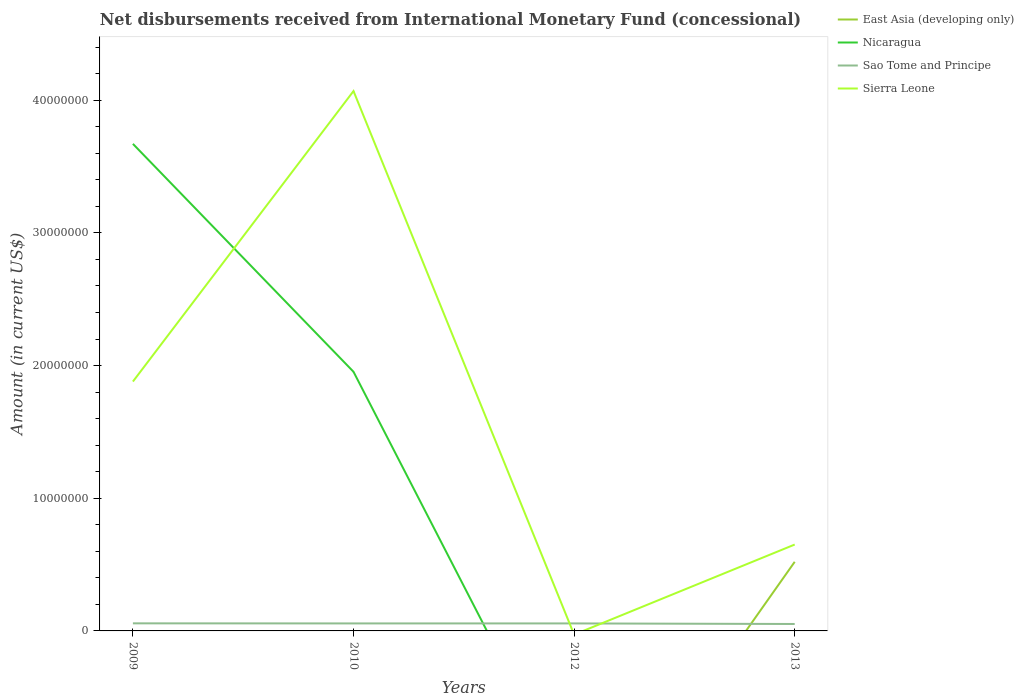Does the line corresponding to Sao Tome and Principe intersect with the line corresponding to Sierra Leone?
Provide a short and direct response. Yes. Across all years, what is the maximum amount of disbursements received from International Monetary Fund in Sao Tome and Principe?
Your answer should be compact. 5.23e+05. What is the total amount of disbursements received from International Monetary Fund in Sierra Leone in the graph?
Provide a short and direct response. 1.23e+07. What is the difference between the highest and the second highest amount of disbursements received from International Monetary Fund in East Asia (developing only)?
Provide a succinct answer. 5.21e+06. Is the amount of disbursements received from International Monetary Fund in Sao Tome and Principe strictly greater than the amount of disbursements received from International Monetary Fund in Sierra Leone over the years?
Provide a succinct answer. No. What is the difference between two consecutive major ticks on the Y-axis?
Offer a very short reply. 1.00e+07. Does the graph contain grids?
Provide a succinct answer. No. How are the legend labels stacked?
Give a very brief answer. Vertical. What is the title of the graph?
Your response must be concise. Net disbursements received from International Monetary Fund (concessional). Does "China" appear as one of the legend labels in the graph?
Provide a succinct answer. No. What is the label or title of the X-axis?
Keep it short and to the point. Years. What is the label or title of the Y-axis?
Keep it short and to the point. Amount (in current US$). What is the Amount (in current US$) of East Asia (developing only) in 2009?
Offer a very short reply. 0. What is the Amount (in current US$) in Nicaragua in 2009?
Keep it short and to the point. 3.67e+07. What is the Amount (in current US$) of Sao Tome and Principe in 2009?
Keep it short and to the point. 5.71e+05. What is the Amount (in current US$) of Sierra Leone in 2009?
Your response must be concise. 1.88e+07. What is the Amount (in current US$) of East Asia (developing only) in 2010?
Make the answer very short. 0. What is the Amount (in current US$) in Nicaragua in 2010?
Offer a terse response. 1.95e+07. What is the Amount (in current US$) of Sao Tome and Principe in 2010?
Your response must be concise. 5.65e+05. What is the Amount (in current US$) of Sierra Leone in 2010?
Make the answer very short. 4.07e+07. What is the Amount (in current US$) in East Asia (developing only) in 2012?
Your answer should be very brief. 0. What is the Amount (in current US$) of Nicaragua in 2012?
Keep it short and to the point. 0. What is the Amount (in current US$) in Sao Tome and Principe in 2012?
Provide a succinct answer. 5.65e+05. What is the Amount (in current US$) of East Asia (developing only) in 2013?
Keep it short and to the point. 5.21e+06. What is the Amount (in current US$) of Nicaragua in 2013?
Ensure brevity in your answer.  0. What is the Amount (in current US$) of Sao Tome and Principe in 2013?
Make the answer very short. 5.23e+05. What is the Amount (in current US$) of Sierra Leone in 2013?
Give a very brief answer. 6.51e+06. Across all years, what is the maximum Amount (in current US$) in East Asia (developing only)?
Give a very brief answer. 5.21e+06. Across all years, what is the maximum Amount (in current US$) of Nicaragua?
Ensure brevity in your answer.  3.67e+07. Across all years, what is the maximum Amount (in current US$) in Sao Tome and Principe?
Keep it short and to the point. 5.71e+05. Across all years, what is the maximum Amount (in current US$) in Sierra Leone?
Offer a very short reply. 4.07e+07. Across all years, what is the minimum Amount (in current US$) of East Asia (developing only)?
Give a very brief answer. 0. Across all years, what is the minimum Amount (in current US$) of Sao Tome and Principe?
Provide a short and direct response. 5.23e+05. Across all years, what is the minimum Amount (in current US$) of Sierra Leone?
Provide a short and direct response. 0. What is the total Amount (in current US$) in East Asia (developing only) in the graph?
Your response must be concise. 5.21e+06. What is the total Amount (in current US$) of Nicaragua in the graph?
Offer a very short reply. 5.62e+07. What is the total Amount (in current US$) in Sao Tome and Principe in the graph?
Provide a succinct answer. 2.22e+06. What is the total Amount (in current US$) in Sierra Leone in the graph?
Give a very brief answer. 6.60e+07. What is the difference between the Amount (in current US$) in Nicaragua in 2009 and that in 2010?
Give a very brief answer. 1.72e+07. What is the difference between the Amount (in current US$) in Sao Tome and Principe in 2009 and that in 2010?
Your answer should be compact. 6000. What is the difference between the Amount (in current US$) in Sierra Leone in 2009 and that in 2010?
Give a very brief answer. -2.19e+07. What is the difference between the Amount (in current US$) of Sao Tome and Principe in 2009 and that in 2012?
Offer a terse response. 6000. What is the difference between the Amount (in current US$) of Sao Tome and Principe in 2009 and that in 2013?
Your response must be concise. 4.80e+04. What is the difference between the Amount (in current US$) in Sierra Leone in 2009 and that in 2013?
Your response must be concise. 1.23e+07. What is the difference between the Amount (in current US$) of Sao Tome and Principe in 2010 and that in 2013?
Your response must be concise. 4.20e+04. What is the difference between the Amount (in current US$) in Sierra Leone in 2010 and that in 2013?
Offer a terse response. 3.42e+07. What is the difference between the Amount (in current US$) of Sao Tome and Principe in 2012 and that in 2013?
Your answer should be very brief. 4.20e+04. What is the difference between the Amount (in current US$) in Nicaragua in 2009 and the Amount (in current US$) in Sao Tome and Principe in 2010?
Provide a short and direct response. 3.61e+07. What is the difference between the Amount (in current US$) in Nicaragua in 2009 and the Amount (in current US$) in Sierra Leone in 2010?
Provide a succinct answer. -3.98e+06. What is the difference between the Amount (in current US$) of Sao Tome and Principe in 2009 and the Amount (in current US$) of Sierra Leone in 2010?
Provide a succinct answer. -4.01e+07. What is the difference between the Amount (in current US$) of Nicaragua in 2009 and the Amount (in current US$) of Sao Tome and Principe in 2012?
Offer a very short reply. 3.61e+07. What is the difference between the Amount (in current US$) of Nicaragua in 2009 and the Amount (in current US$) of Sao Tome and Principe in 2013?
Ensure brevity in your answer.  3.62e+07. What is the difference between the Amount (in current US$) in Nicaragua in 2009 and the Amount (in current US$) in Sierra Leone in 2013?
Your response must be concise. 3.02e+07. What is the difference between the Amount (in current US$) in Sao Tome and Principe in 2009 and the Amount (in current US$) in Sierra Leone in 2013?
Offer a terse response. -5.94e+06. What is the difference between the Amount (in current US$) of Nicaragua in 2010 and the Amount (in current US$) of Sao Tome and Principe in 2012?
Make the answer very short. 1.90e+07. What is the difference between the Amount (in current US$) of Nicaragua in 2010 and the Amount (in current US$) of Sao Tome and Principe in 2013?
Give a very brief answer. 1.90e+07. What is the difference between the Amount (in current US$) in Nicaragua in 2010 and the Amount (in current US$) in Sierra Leone in 2013?
Give a very brief answer. 1.30e+07. What is the difference between the Amount (in current US$) of Sao Tome and Principe in 2010 and the Amount (in current US$) of Sierra Leone in 2013?
Keep it short and to the point. -5.94e+06. What is the difference between the Amount (in current US$) in Sao Tome and Principe in 2012 and the Amount (in current US$) in Sierra Leone in 2013?
Give a very brief answer. -5.94e+06. What is the average Amount (in current US$) of East Asia (developing only) per year?
Keep it short and to the point. 1.30e+06. What is the average Amount (in current US$) of Nicaragua per year?
Offer a terse response. 1.41e+07. What is the average Amount (in current US$) of Sao Tome and Principe per year?
Make the answer very short. 5.56e+05. What is the average Amount (in current US$) in Sierra Leone per year?
Keep it short and to the point. 1.65e+07. In the year 2009, what is the difference between the Amount (in current US$) of Nicaragua and Amount (in current US$) of Sao Tome and Principe?
Your answer should be compact. 3.61e+07. In the year 2009, what is the difference between the Amount (in current US$) of Nicaragua and Amount (in current US$) of Sierra Leone?
Give a very brief answer. 1.79e+07. In the year 2009, what is the difference between the Amount (in current US$) in Sao Tome and Principe and Amount (in current US$) in Sierra Leone?
Your answer should be compact. -1.82e+07. In the year 2010, what is the difference between the Amount (in current US$) in Nicaragua and Amount (in current US$) in Sao Tome and Principe?
Your answer should be compact. 1.90e+07. In the year 2010, what is the difference between the Amount (in current US$) of Nicaragua and Amount (in current US$) of Sierra Leone?
Keep it short and to the point. -2.12e+07. In the year 2010, what is the difference between the Amount (in current US$) of Sao Tome and Principe and Amount (in current US$) of Sierra Leone?
Ensure brevity in your answer.  -4.01e+07. In the year 2013, what is the difference between the Amount (in current US$) of East Asia (developing only) and Amount (in current US$) of Sao Tome and Principe?
Ensure brevity in your answer.  4.69e+06. In the year 2013, what is the difference between the Amount (in current US$) in East Asia (developing only) and Amount (in current US$) in Sierra Leone?
Your answer should be very brief. -1.30e+06. In the year 2013, what is the difference between the Amount (in current US$) in Sao Tome and Principe and Amount (in current US$) in Sierra Leone?
Keep it short and to the point. -5.99e+06. What is the ratio of the Amount (in current US$) in Nicaragua in 2009 to that in 2010?
Your answer should be very brief. 1.88. What is the ratio of the Amount (in current US$) in Sao Tome and Principe in 2009 to that in 2010?
Ensure brevity in your answer.  1.01. What is the ratio of the Amount (in current US$) of Sierra Leone in 2009 to that in 2010?
Provide a succinct answer. 0.46. What is the ratio of the Amount (in current US$) in Sao Tome and Principe in 2009 to that in 2012?
Make the answer very short. 1.01. What is the ratio of the Amount (in current US$) of Sao Tome and Principe in 2009 to that in 2013?
Ensure brevity in your answer.  1.09. What is the ratio of the Amount (in current US$) of Sierra Leone in 2009 to that in 2013?
Ensure brevity in your answer.  2.89. What is the ratio of the Amount (in current US$) of Sao Tome and Principe in 2010 to that in 2012?
Keep it short and to the point. 1. What is the ratio of the Amount (in current US$) in Sao Tome and Principe in 2010 to that in 2013?
Offer a terse response. 1.08. What is the ratio of the Amount (in current US$) in Sierra Leone in 2010 to that in 2013?
Keep it short and to the point. 6.25. What is the ratio of the Amount (in current US$) of Sao Tome and Principe in 2012 to that in 2013?
Offer a terse response. 1.08. What is the difference between the highest and the second highest Amount (in current US$) of Sao Tome and Principe?
Provide a succinct answer. 6000. What is the difference between the highest and the second highest Amount (in current US$) in Sierra Leone?
Your answer should be very brief. 2.19e+07. What is the difference between the highest and the lowest Amount (in current US$) in East Asia (developing only)?
Offer a terse response. 5.21e+06. What is the difference between the highest and the lowest Amount (in current US$) of Nicaragua?
Provide a succinct answer. 3.67e+07. What is the difference between the highest and the lowest Amount (in current US$) of Sao Tome and Principe?
Make the answer very short. 4.80e+04. What is the difference between the highest and the lowest Amount (in current US$) in Sierra Leone?
Provide a short and direct response. 4.07e+07. 